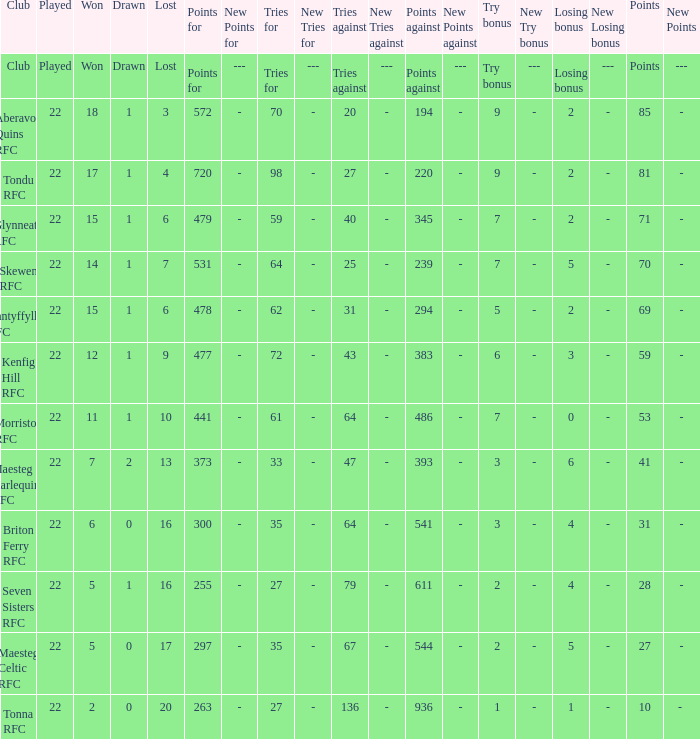What club got 239 points against? Skewen RFC. 